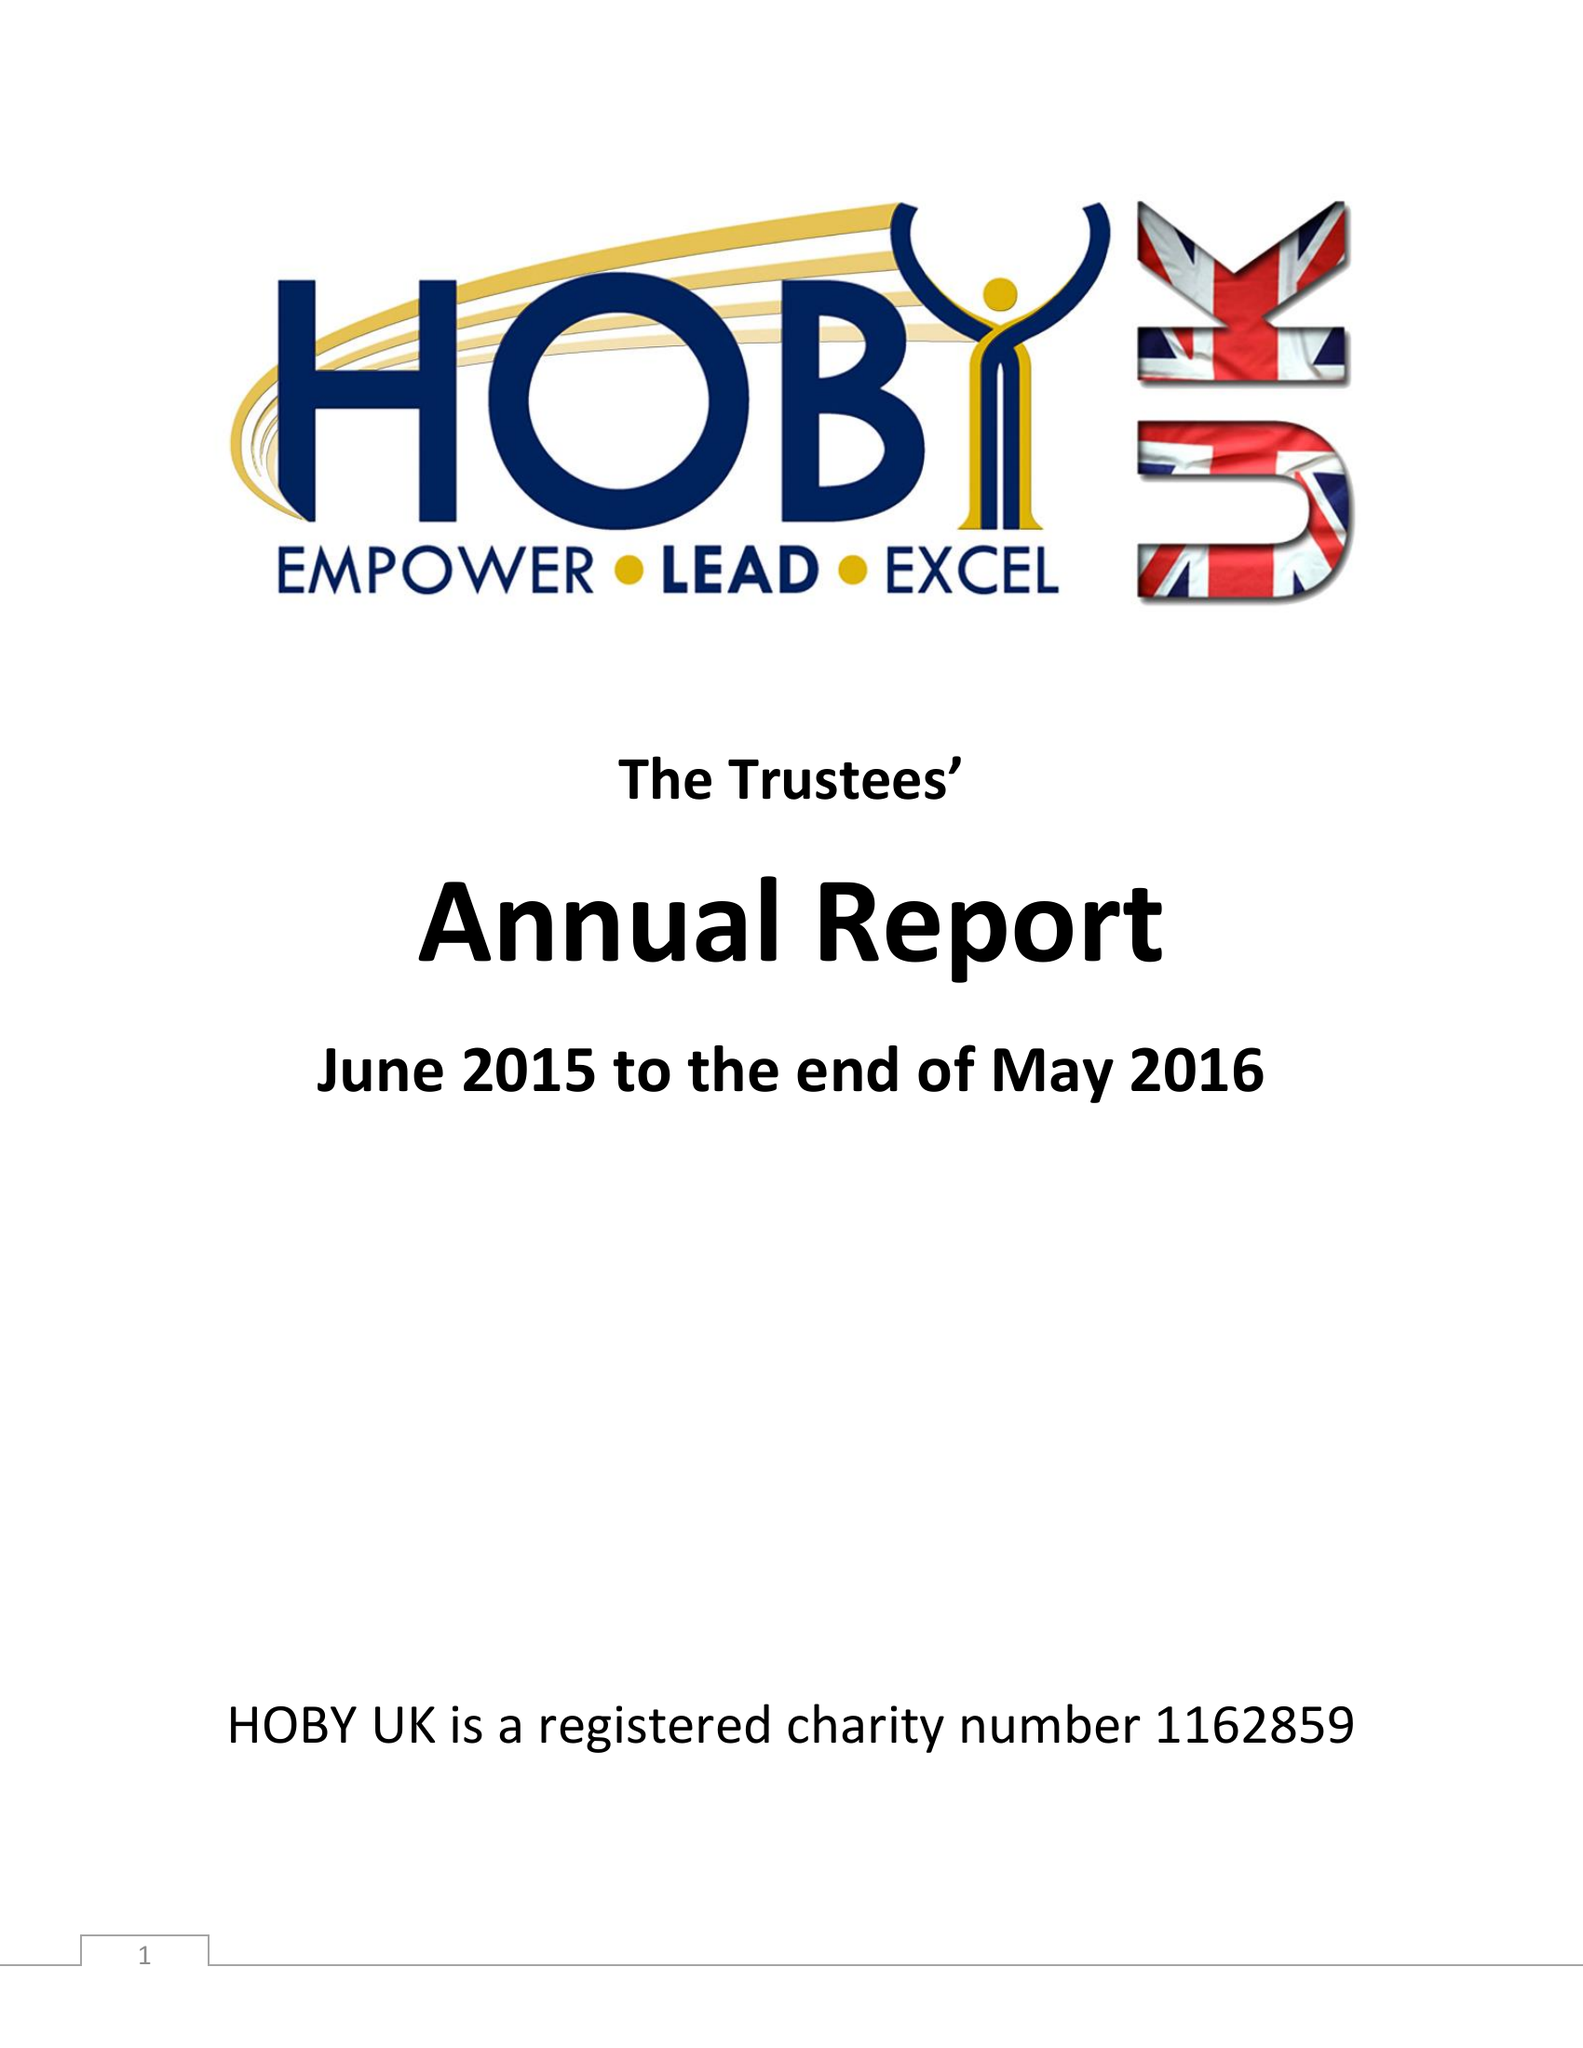What is the value for the address__street_line?
Answer the question using a single word or phrase. None 